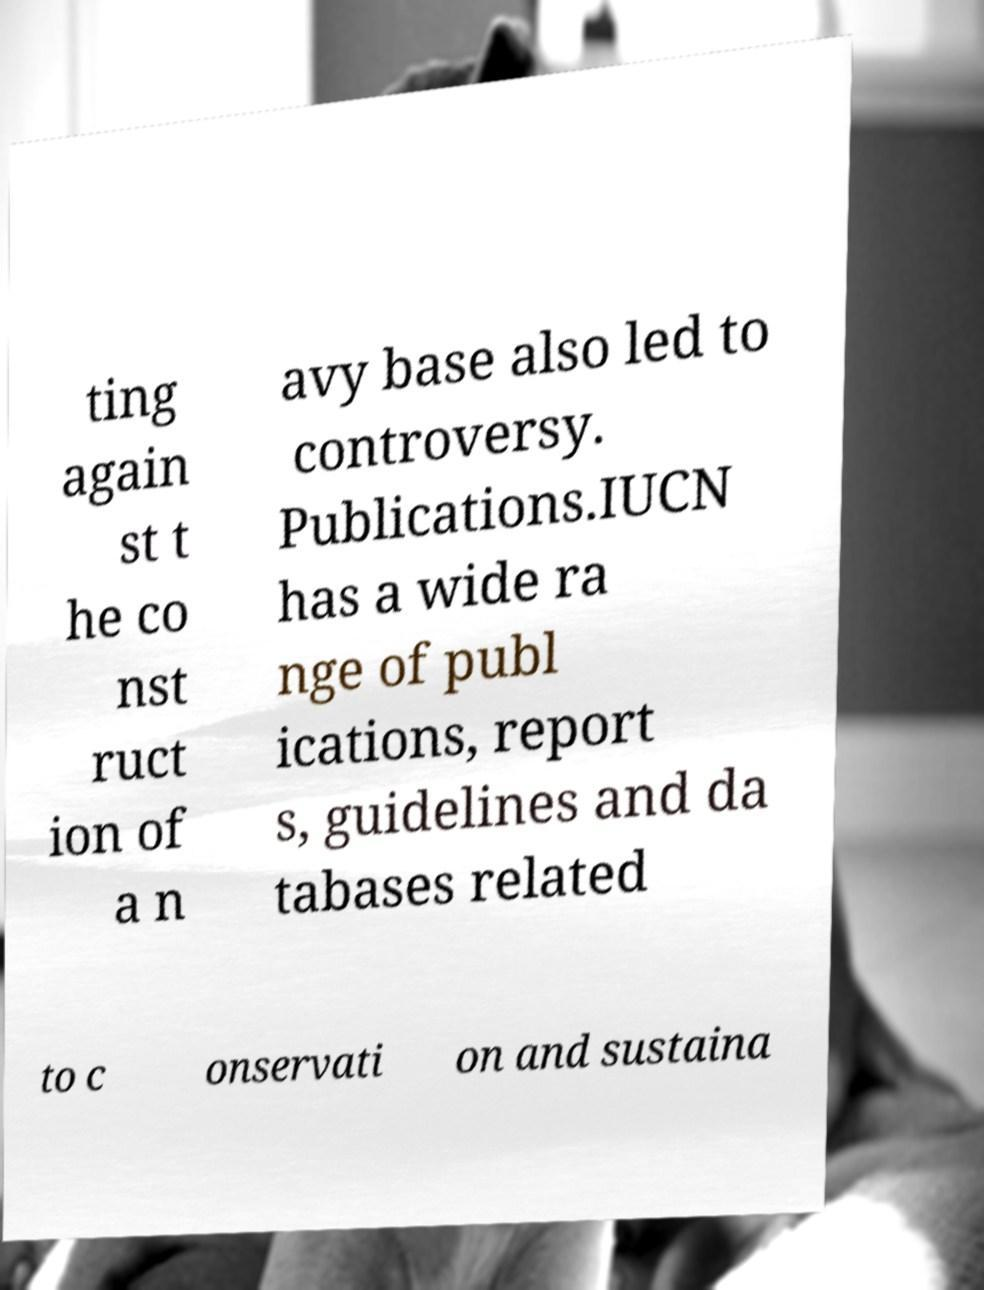What messages or text are displayed in this image? I need them in a readable, typed format. ting again st t he co nst ruct ion of a n avy base also led to controversy. Publications.IUCN has a wide ra nge of publ ications, report s, guidelines and da tabases related to c onservati on and sustaina 